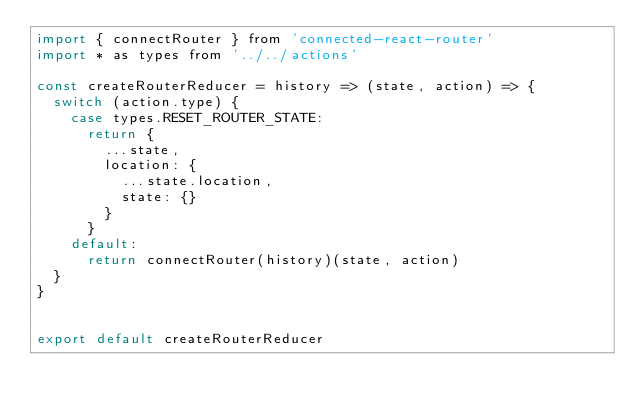<code> <loc_0><loc_0><loc_500><loc_500><_JavaScript_>import { connectRouter } from 'connected-react-router'
import * as types from '../../actions'

const createRouterReducer = history => (state, action) => {
  switch (action.type) {
    case types.RESET_ROUTER_STATE:
      return {
        ...state,
        location: {
          ...state.location,
          state: {}
        }
      }
    default:
      return connectRouter(history)(state, action)
  }
}


export default createRouterReducer</code> 